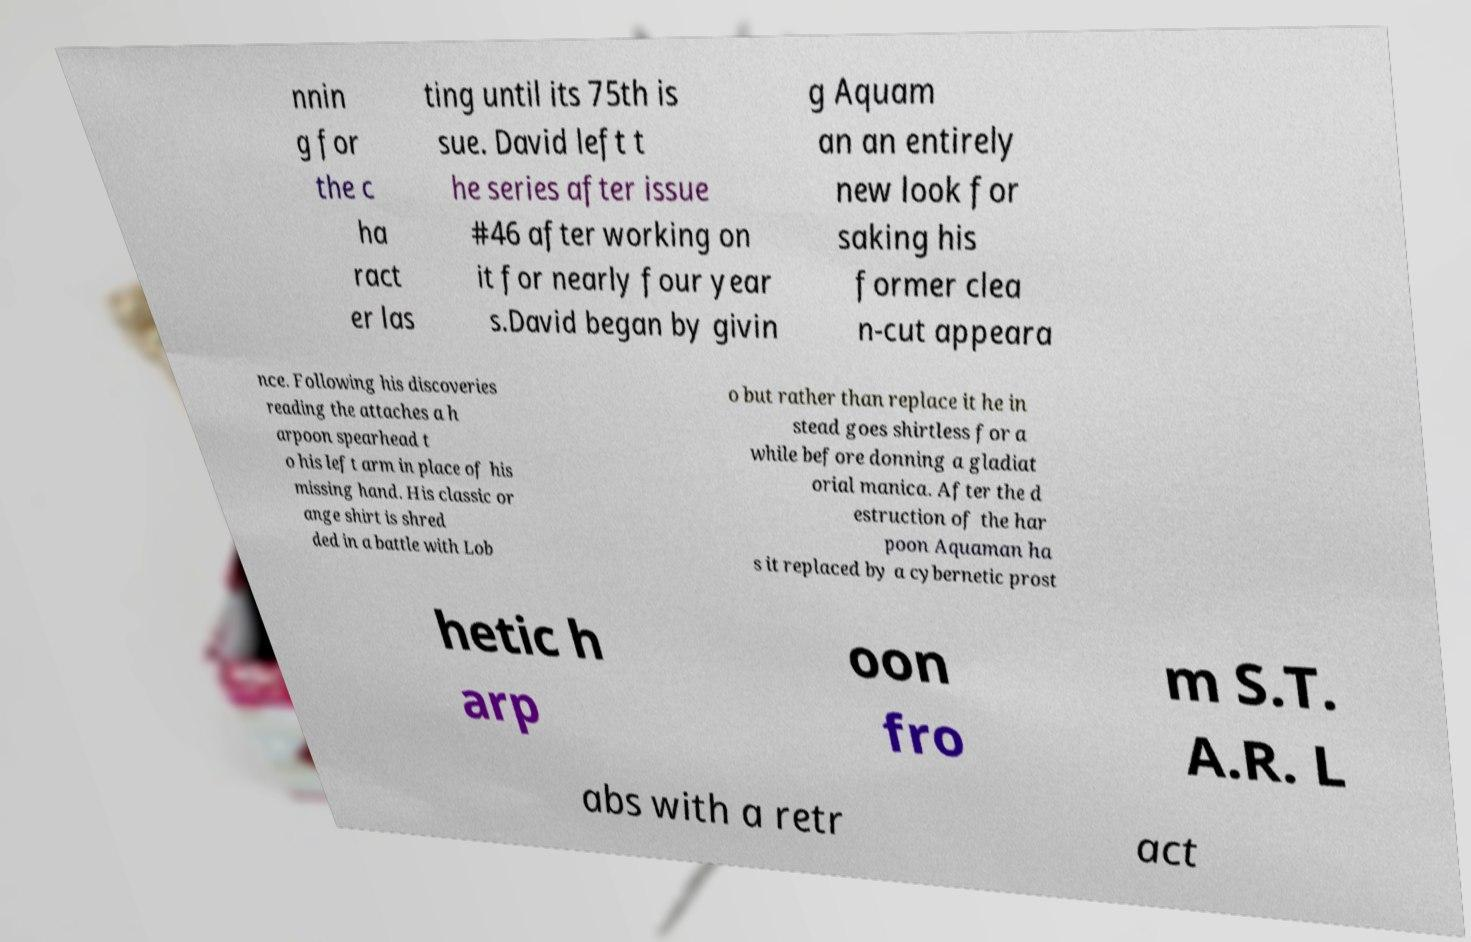Can you accurately transcribe the text from the provided image for me? nnin g for the c ha ract er las ting until its 75th is sue. David left t he series after issue #46 after working on it for nearly four year s.David began by givin g Aquam an an entirely new look for saking his former clea n-cut appeara nce. Following his discoveries reading the attaches a h arpoon spearhead t o his left arm in place of his missing hand. His classic or ange shirt is shred ded in a battle with Lob o but rather than replace it he in stead goes shirtless for a while before donning a gladiat orial manica. After the d estruction of the har poon Aquaman ha s it replaced by a cybernetic prost hetic h arp oon fro m S.T. A.R. L abs with a retr act 